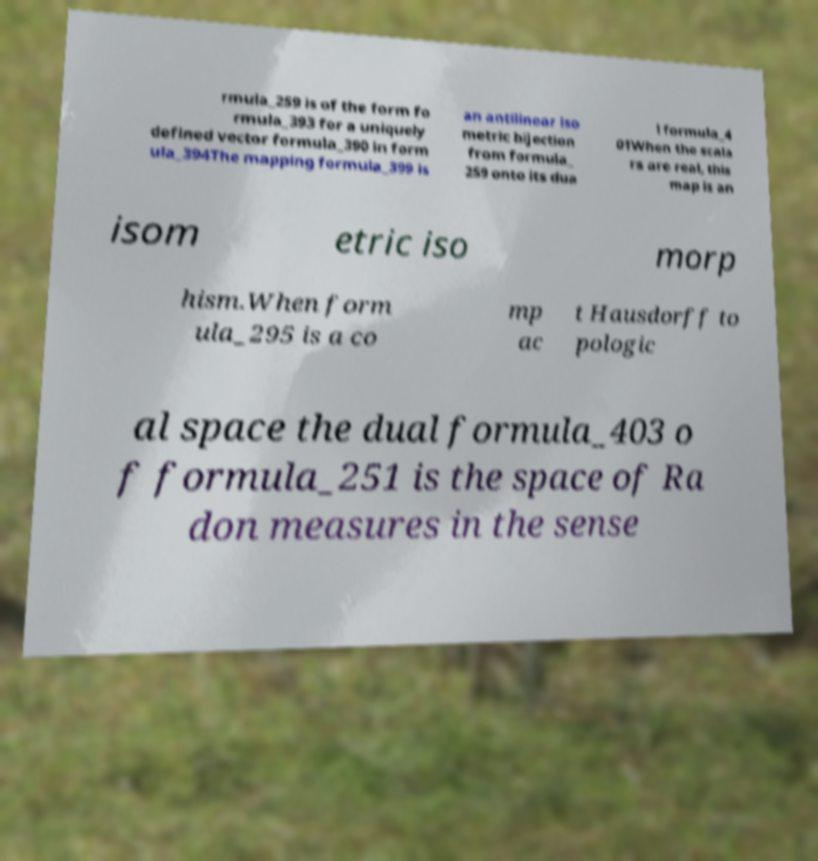Please identify and transcribe the text found in this image. rmula_259 is of the form fo rmula_393 for a uniquely defined vector formula_390 in form ula_394The mapping formula_399 is an antilinear iso metric bijection from formula_ 259 onto its dua l formula_4 01When the scala rs are real, this map is an isom etric iso morp hism.When form ula_295 is a co mp ac t Hausdorff to pologic al space the dual formula_403 o f formula_251 is the space of Ra don measures in the sense 